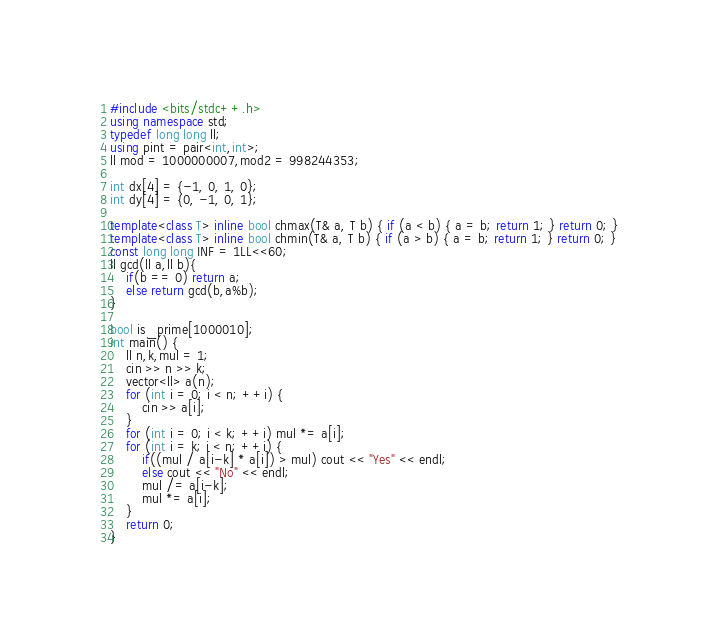<code> <loc_0><loc_0><loc_500><loc_500><_C++_>#include <bits/stdc++.h>
using namespace std;
typedef long long ll;
using pint = pair<int,int>;
ll mod = 1000000007,mod2 = 998244353;

int dx[4] = {-1, 0, 1, 0};
int dy[4] = {0, -1, 0, 1};

template<class T> inline bool chmax(T& a, T b) { if (a < b) { a = b; return 1; } return 0; }
template<class T> inline bool chmin(T& a, T b) { if (a > b) { a = b; return 1; } return 0; }
const long long INF = 1LL<<60;
ll gcd(ll a,ll b){
    if(b == 0) return a;
    else return gcd(b,a%b);
}

bool is_prime[1000010];
int main() {
    ll n,k,mul = 1;
    cin >> n >> k;
    vector<ll> a(n);
    for (int i = 0; i < n; ++i) {
        cin >> a[i];
    }
    for (int i = 0; i < k; ++i) mul *= a[i];
    for (int i = k; i < n; ++i) {
        if((mul / a[i-k] * a[i]) > mul) cout << "Yes" << endl;
        else cout << "No" << endl;
        mul /= a[i-k];
        mul *= a[i];
    }
    return 0;
}</code> 